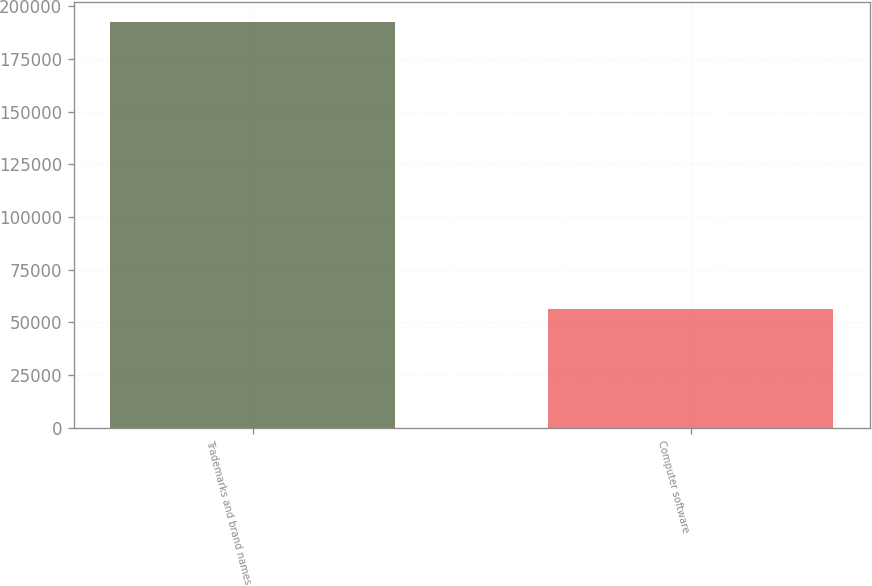Convert chart. <chart><loc_0><loc_0><loc_500><loc_500><bar_chart><fcel>Trademarks and brand names<fcel>Computer software<nl><fcel>192440<fcel>56356<nl></chart> 